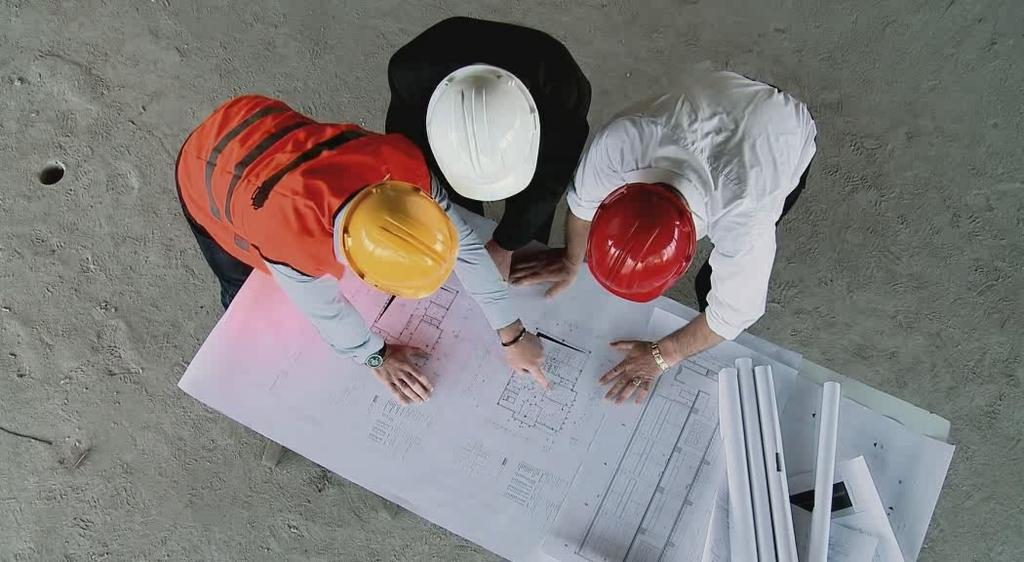How many people are in the image? There are three persons in the image. What are the persons wearing on their heads? The persons are wearing helmets. What are the persons looking at in the image? The persons are looking at an engineer's plan. What other objects can be seen in the image? There are paper rolls in the image. What type of gate can be seen in the image? There is no gate present in the image. How many buns are visible in the image? There are no buns present in the image. 